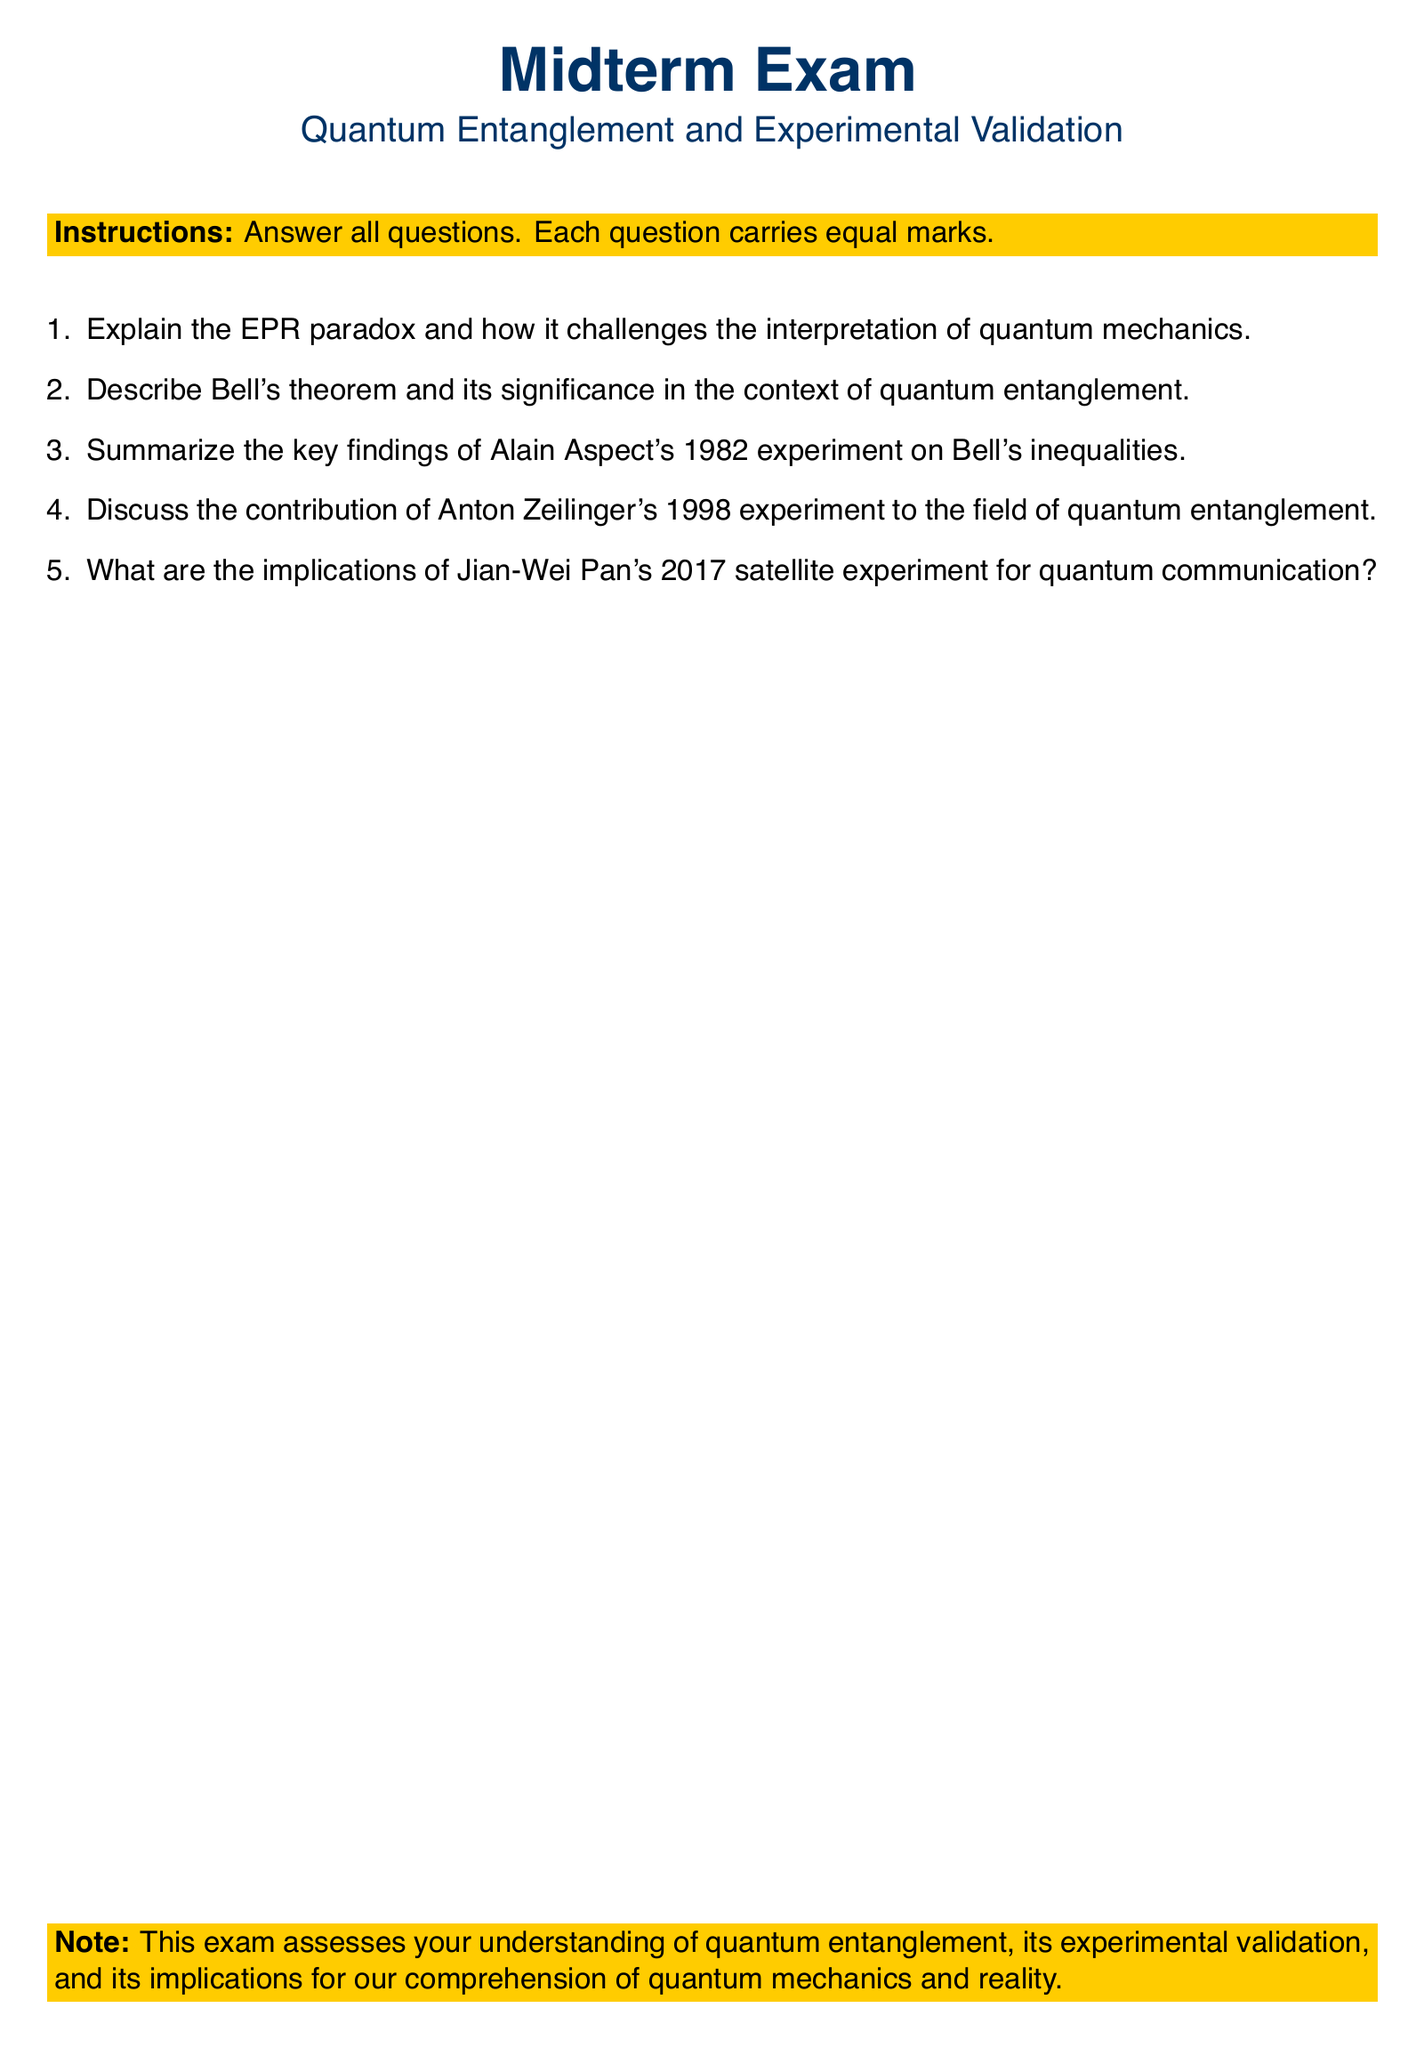What is the title of this midterm exam? The title is stated prominently at the beginning of the document.
Answer: Quantum Entanglement and Experimental Validation What year was Alain Aspect's experiment conducted? The document specifically mentions the year of Alain Aspect's experiment.
Answer: 1982 What type of questions are included in the exam? The document specifies that the questions are designed to assess understanding.
Answer: Short-answer questions Who conducted the 1998 experiment on quantum entanglement? The document names Anton Zeilinger as the individual associated with the 1998 experiment.
Answer: Anton Zeilinger What is the significance of Bell's theorem according to the exam questions? The document points out the need for understanding the significance of Bell's theorem in quantum entanglement.
Answer: Its significance in the context of quantum entanglement What major concept does the EPR paradox challenge? The document explicitly states that the EPR paradox challenges the interpretation of quantum mechanics.
Answer: Interpretation of quantum mechanics In which year was Jian-Wei Pan's satellite experiment conducted? The document refers to the year of Jian-Wei Pan's satellite experiment.
Answer: 2017 What is the focus of the midterm exam based on the note at the end of the document? The note clearly states the focus of the exam regarding quantum mechanics understanding.
Answer: Quantum entanglement and its implications 